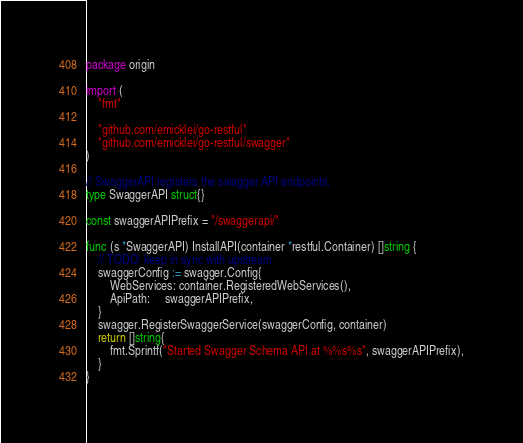<code> <loc_0><loc_0><loc_500><loc_500><_Go_>package origin

import (
	"fmt"

	"github.com/emicklei/go-restful"
	"github.com/emicklei/go-restful/swagger"
)

// SwaggerAPI registers the swagger API endpoints.
type SwaggerAPI struct{}

const swaggerAPIPrefix = "/swaggerapi/"

func (s *SwaggerAPI) InstallAPI(container *restful.Container) []string {
	// TODO: keep in sync with upstream
	swaggerConfig := swagger.Config{
		WebServices: container.RegisteredWebServices(),
		ApiPath:     swaggerAPIPrefix,
	}
	swagger.RegisterSwaggerService(swaggerConfig, container)
	return []string{
		fmt.Sprintf("Started Swagger Schema API at %%s%s", swaggerAPIPrefix),
	}
}
</code> 